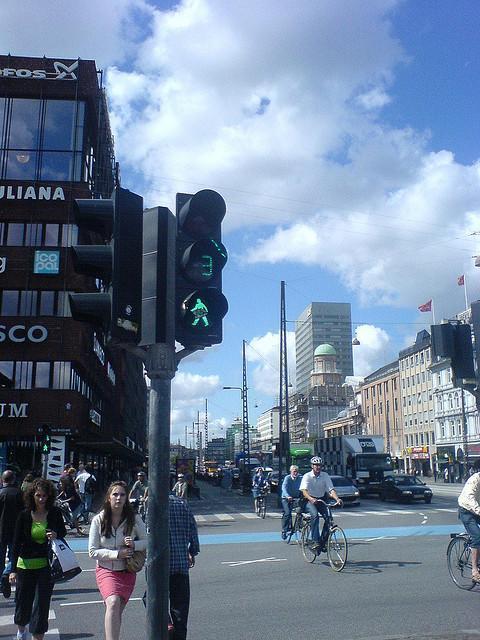How many seconds do the pedestrians have left on the green light?
Give a very brief answer. 3. How many bikes are visible?
Give a very brief answer. 4. How many people can be seen?
Give a very brief answer. 4. How many trucks are visible?
Give a very brief answer. 1. How many umbrellas in the photo?
Give a very brief answer. 0. 